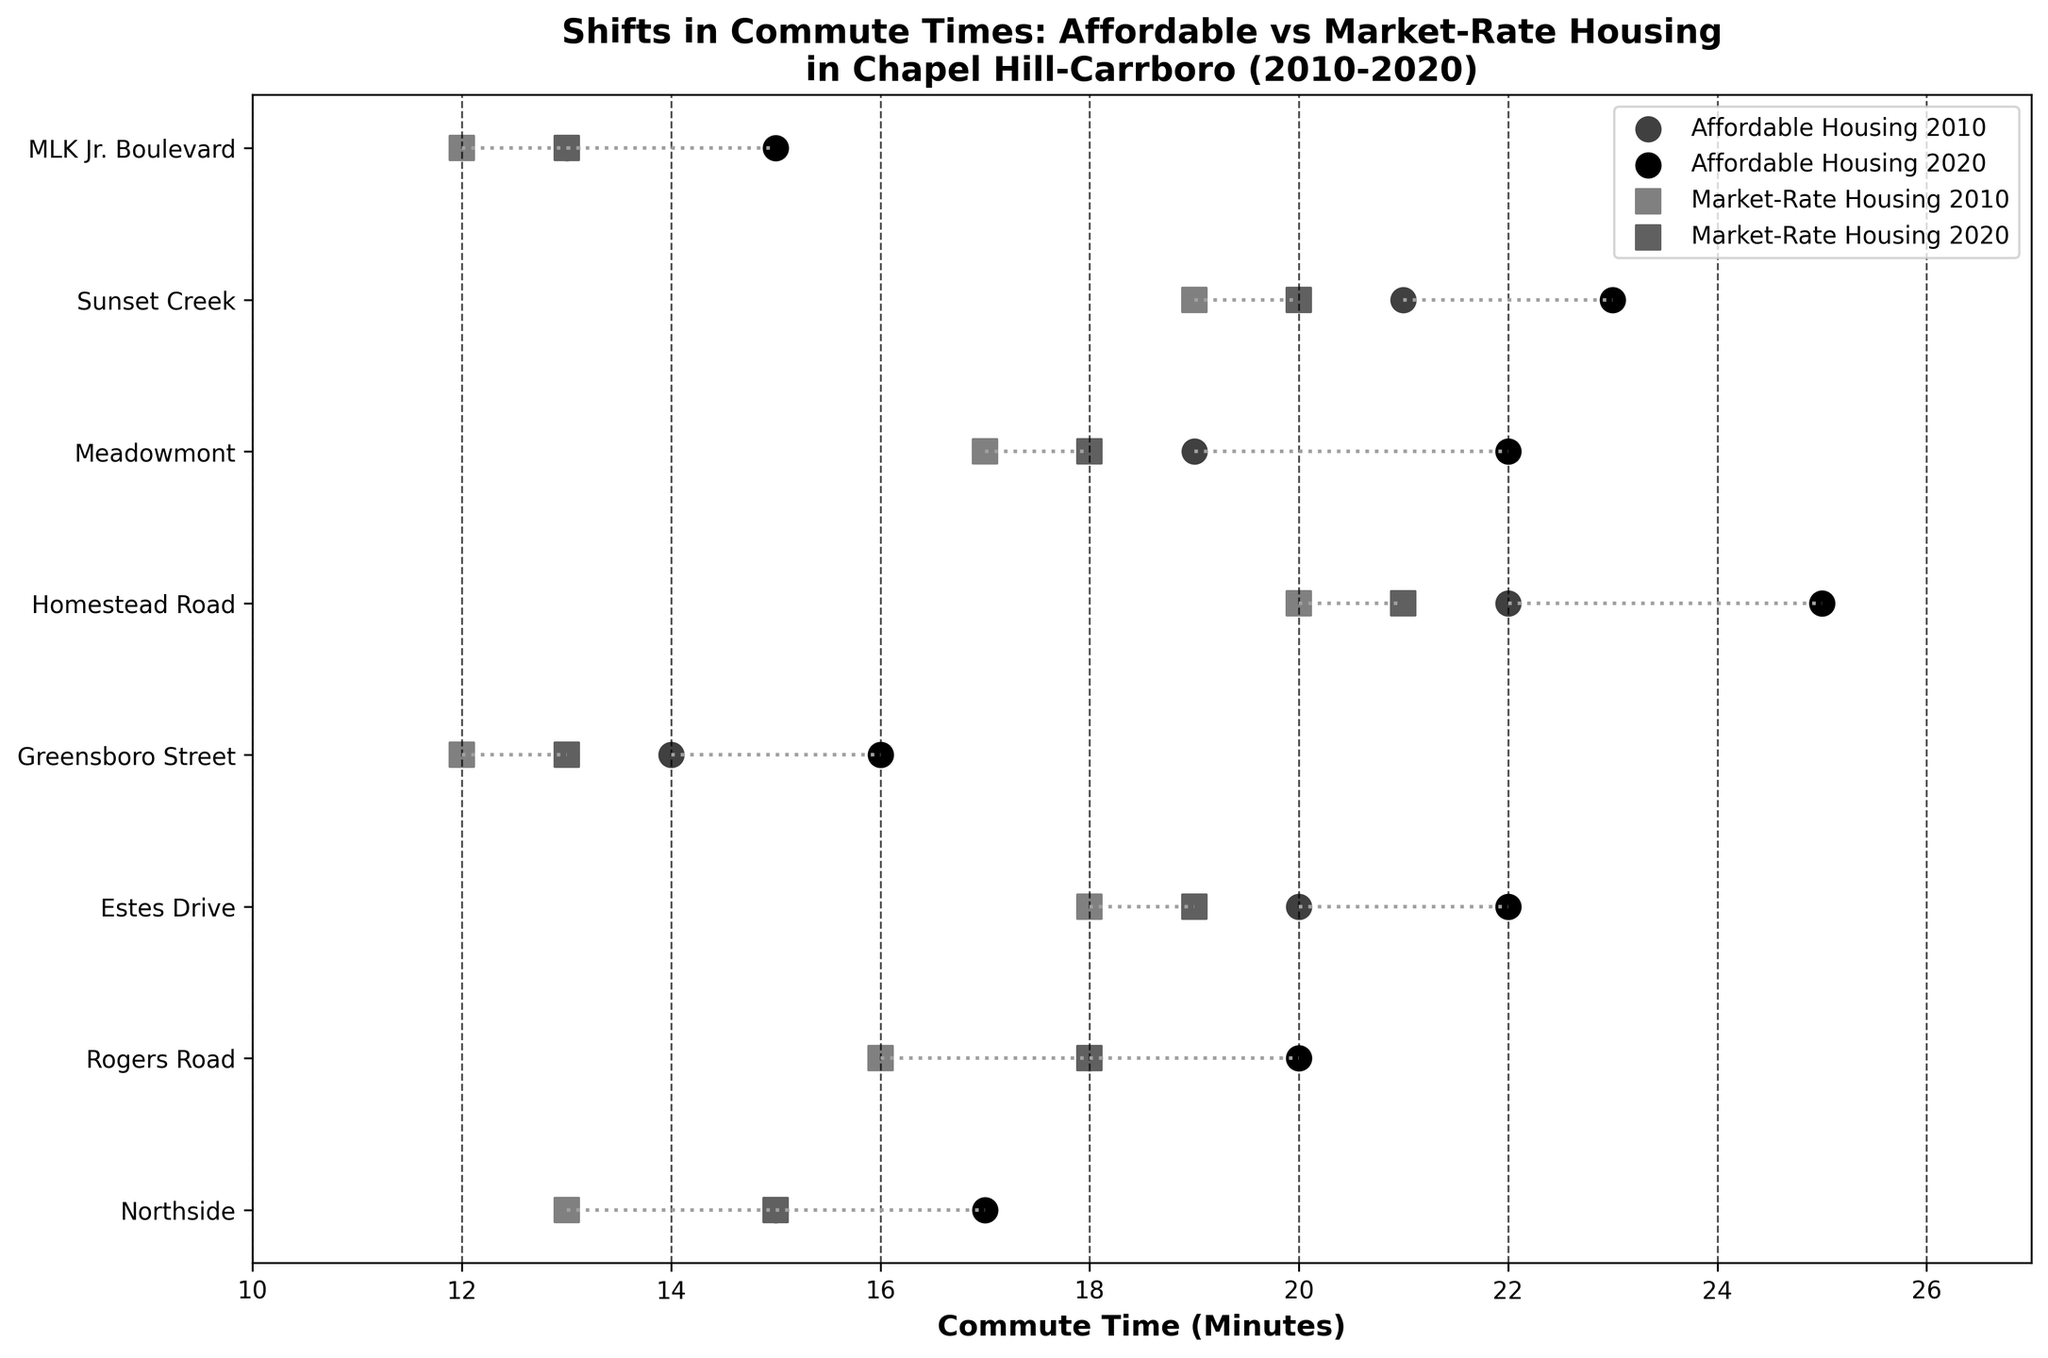What is the title of the figure? The title of the figure is displayed at the top of the plot. It summarizes the focus of the visual, which is about commute times for residents in different housing types within Chapel Hill-Carrboro between 2010 and 2020.
Answer: Shifts in Commute Times: Affordable vs Market-Rate Housing in Chapel Hill-Carrboro (2010-2020) How many neighborhoods are represented in the figure? The y-axis of the plot lists the neighborhoods included in the study. By counting each label, you can determine the total number of neighborhoods represented.
Answer: 8 Which neighborhood saw the greatest increase in commute time for residents in affordable housing units? To find this, compare the distances between the 2010 and 2020 commute times for affordable housing units across all neighborhoods and identify the one with the largest difference.
Answer: Homestead Road What are the commute times for Market-Rate Housing in Estes Drive in 2010 and 2020? Look at the data points corresponding to Market-Rate Housing in Estes Drive and note the x-axis values for both 2010 and 2020.
Answer: 18 minutes in 2010 and 19 minutes in 2020 For which neighborhood did the commute times for affordable housing and market-rate housing remain the closest in 2020? Compare the differences in the 2020 commute times between affordable and market-rate housing across all neighborhoods and find the smallest difference.
Answer: Greensboro Street Which type of housing saw a consistent increase in commute times across all neighborhoods? To answer this, observe if either affordable or market-rate housing commute times consistently went up in all the neighborhoods from 2010 to 2020.
Answer: Affordable Housing How does the commute time change for affordable housing in Meadowmont compare to that for market-rate housing in the same neighborhood? Calculate the change in commute times for both housing types in Meadowmont by subtracting the 2010 times from the 2020 times and then compare.
Answer: Increase of 3 minutes for Affordable Housing and 1 minute for Market-Rate Housing Which neighborhood had the smallest increase in commute times for market-rate housing between 2010 and 2020? Identify the neighborhood with the smallest difference between the 2010 and 2020 commute times for market-rate housing units.
Answer: Estes Drive On average, how much did commute times increase for affordable housing units across all neighborhoods? Calculate the increase for each neighborhood's affordable housing units, sum these increases, and then divide by the number of neighborhoods.
Answer: 2.25 minutes 